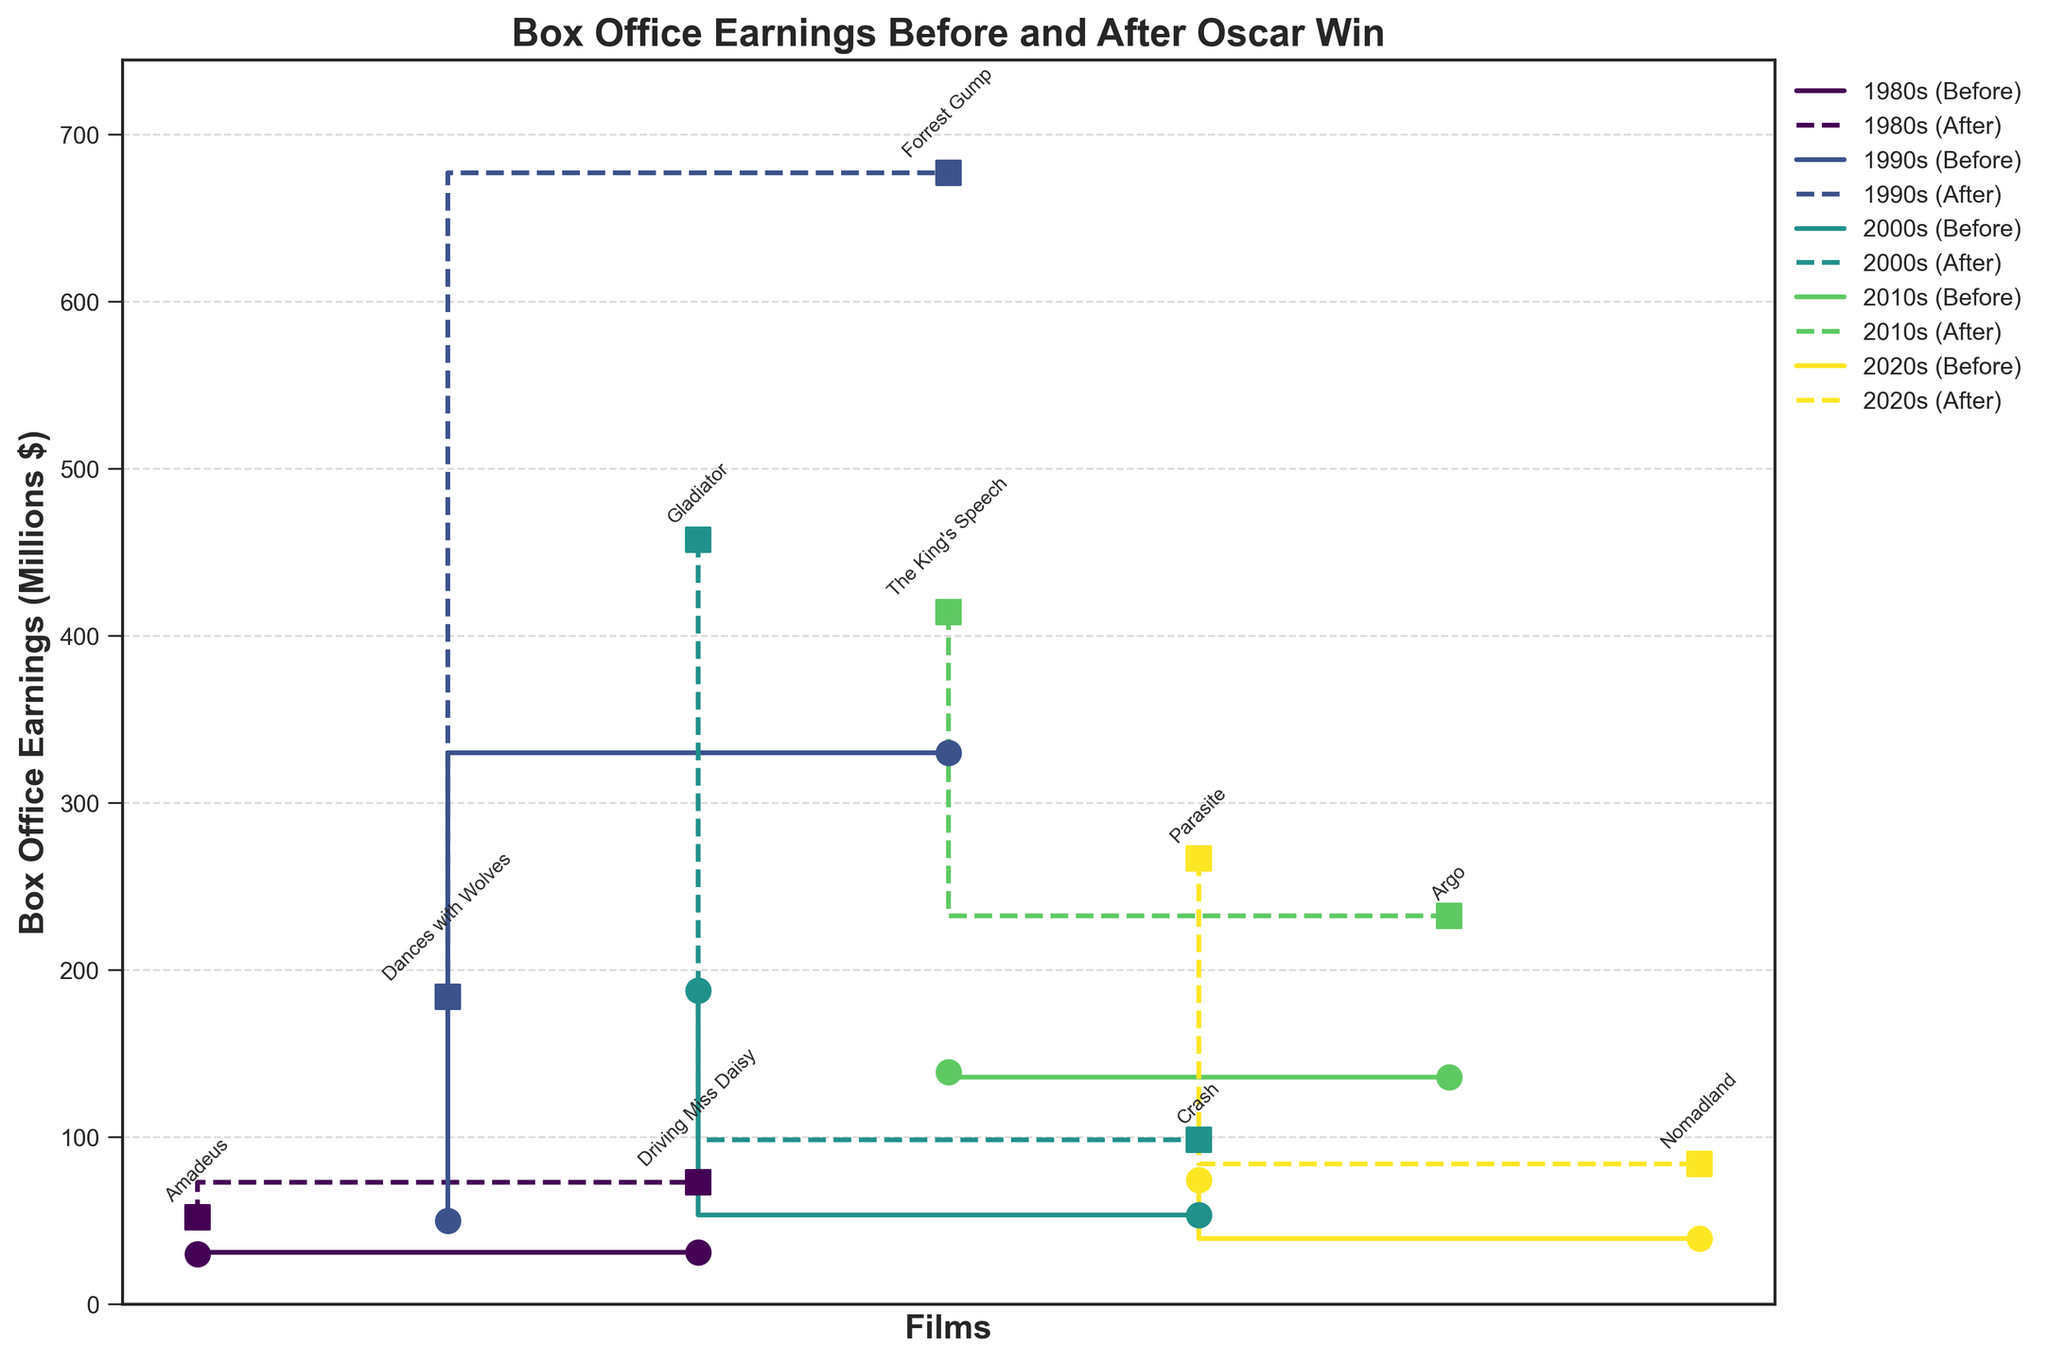What's the title of the plot? The title is usually placed at the top of the figure. In this plot, the title is prominently displayed in bold text.
Answer: Box Office Earnings Before and After Oscar Win What is the color scheme used for different decades? The plot uses a color gradient where the colors change gradually from one end of the spectrum to the other. This helps differentiate each decade.
Answer: A gradient from light to dark (e.g., from yellow to purple) How many films from the 2020s are included in the plot? We look at the unique films marked under the 2020s decade, which can be identified through annotations near the data points.
Answer: Two films Which Oscar-winning film from the 2000s had the highest box office earnings after the Oscar? We locate the films from the 2000s in the plot and compare the box office earnings after Oscar wins. The film with the highest value is in bold.
Answer: Gladiator How much did 'Forrest Gump' earn after winning the Oscar compared to before? Find 'Forrest Gump' among the films in the 1990s. Compare its box office earnings before and after winning the Oscar.
Answer: $347 million more Which decade saw the largest increase in box office earnings after Oscar wins on average? Calculate the increase for each film in a decade and then find the decade with the highest average increase in earnings.
Answer: 1990s Which film had the highest percentage increase in box office earnings after winning the Oscar? For each film, calculate the percentage increase as (BoxOfficeAfterOscar - BoxOfficeBeforeOscar) / BoxOfficeBeforeOscar * 100. Find the film with the highest percentage.
Answer: Driving Miss Daisy What’s the difference in box office earnings for 'The King's Speech' before and after winning the Oscar? Identify the point for 'The King's Speech' in the 2010s segment. Subtract the box office earnings before from after.
Answer: $275.4 million Between 'Parasite' and 'Nomadland,' which had a larger absolute increase in box office earnings after the Oscar? Compare the difference in earnings before and after the Oscar for both 'Parasite' and 'Nomadland'. The one with the larger difference has the larger increase.
Answer: Parasite Does the plot show any films where the box office earnings were higher before winning the Oscar than after? Check the stair plot step functions for all films to see if there are any steps downwards, indicating higher earnings before the Oscar.
Answer: No 